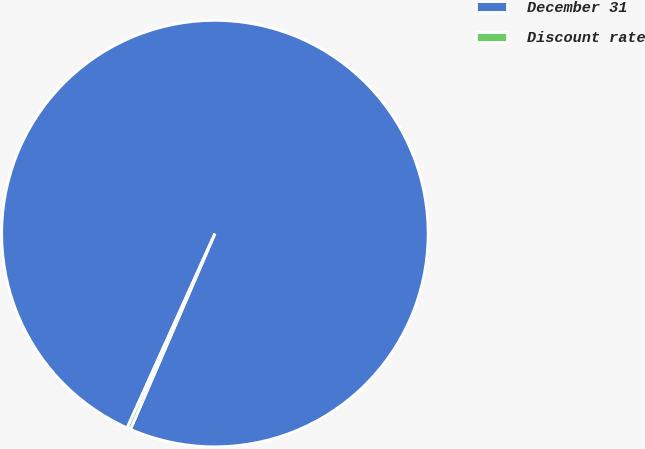Convert chart. <chart><loc_0><loc_0><loc_500><loc_500><pie_chart><fcel>December 31<fcel>Discount rate<nl><fcel>99.73%<fcel>0.27%<nl></chart> 